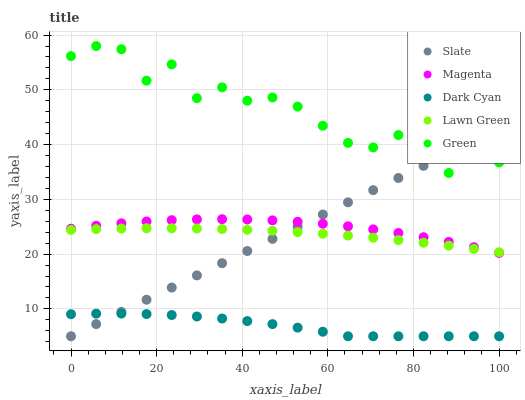Does Dark Cyan have the minimum area under the curve?
Answer yes or no. Yes. Does Green have the maximum area under the curve?
Answer yes or no. Yes. Does Lawn Green have the minimum area under the curve?
Answer yes or no. No. Does Lawn Green have the maximum area under the curve?
Answer yes or no. No. Is Slate the smoothest?
Answer yes or no. Yes. Is Green the roughest?
Answer yes or no. Yes. Is Lawn Green the smoothest?
Answer yes or no. No. Is Lawn Green the roughest?
Answer yes or no. No. Does Dark Cyan have the lowest value?
Answer yes or no. Yes. Does Lawn Green have the lowest value?
Answer yes or no. No. Does Green have the highest value?
Answer yes or no. Yes. Does Lawn Green have the highest value?
Answer yes or no. No. Is Dark Cyan less than Lawn Green?
Answer yes or no. Yes. Is Green greater than Lawn Green?
Answer yes or no. Yes. Does Slate intersect Magenta?
Answer yes or no. Yes. Is Slate less than Magenta?
Answer yes or no. No. Is Slate greater than Magenta?
Answer yes or no. No. Does Dark Cyan intersect Lawn Green?
Answer yes or no. No. 